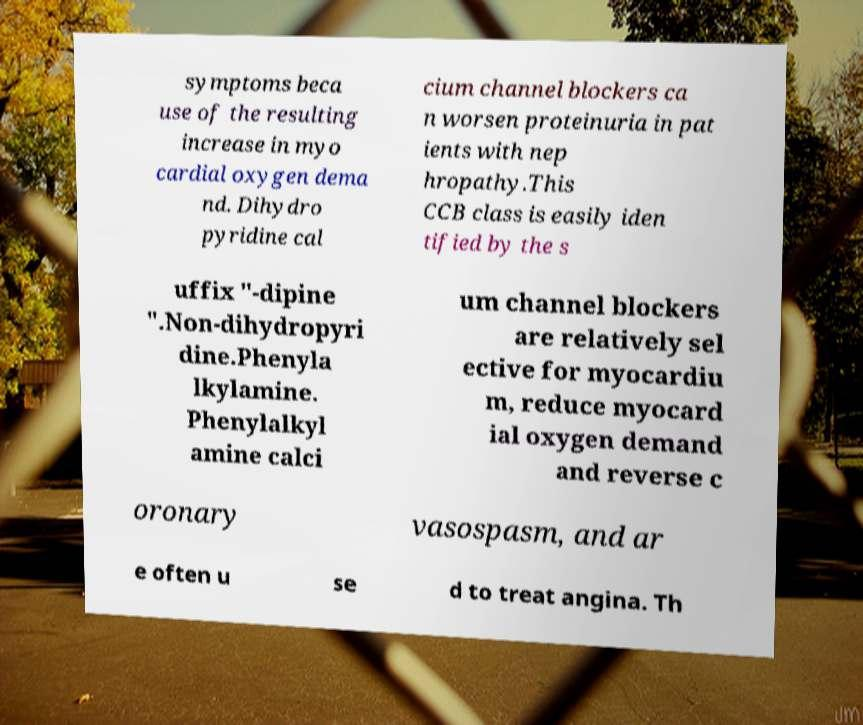Please read and relay the text visible in this image. What does it say? symptoms beca use of the resulting increase in myo cardial oxygen dema nd. Dihydro pyridine cal cium channel blockers ca n worsen proteinuria in pat ients with nep hropathy.This CCB class is easily iden tified by the s uffix "-dipine ".Non-dihydropyri dine.Phenyla lkylamine. Phenylalkyl amine calci um channel blockers are relatively sel ective for myocardiu m, reduce myocard ial oxygen demand and reverse c oronary vasospasm, and ar e often u se d to treat angina. Th 